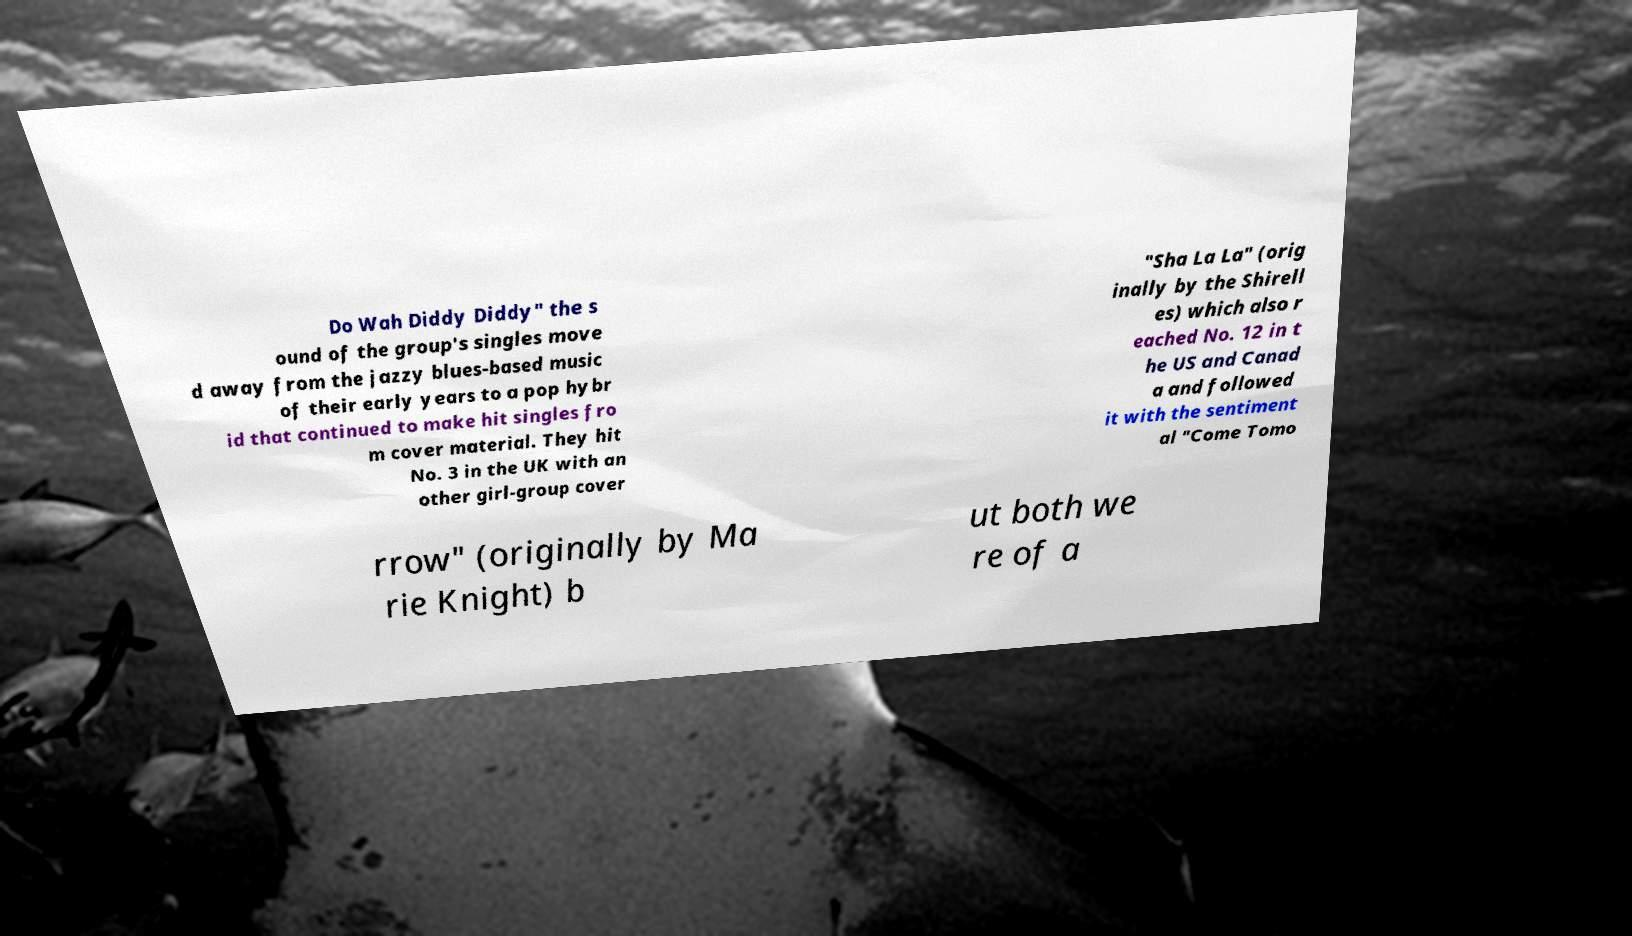I need the written content from this picture converted into text. Can you do that? Do Wah Diddy Diddy" the s ound of the group's singles move d away from the jazzy blues-based music of their early years to a pop hybr id that continued to make hit singles fro m cover material. They hit No. 3 in the UK with an other girl-group cover "Sha La La" (orig inally by the Shirell es) which also r eached No. 12 in t he US and Canad a and followed it with the sentiment al "Come Tomo rrow" (originally by Ma rie Knight) b ut both we re of a 